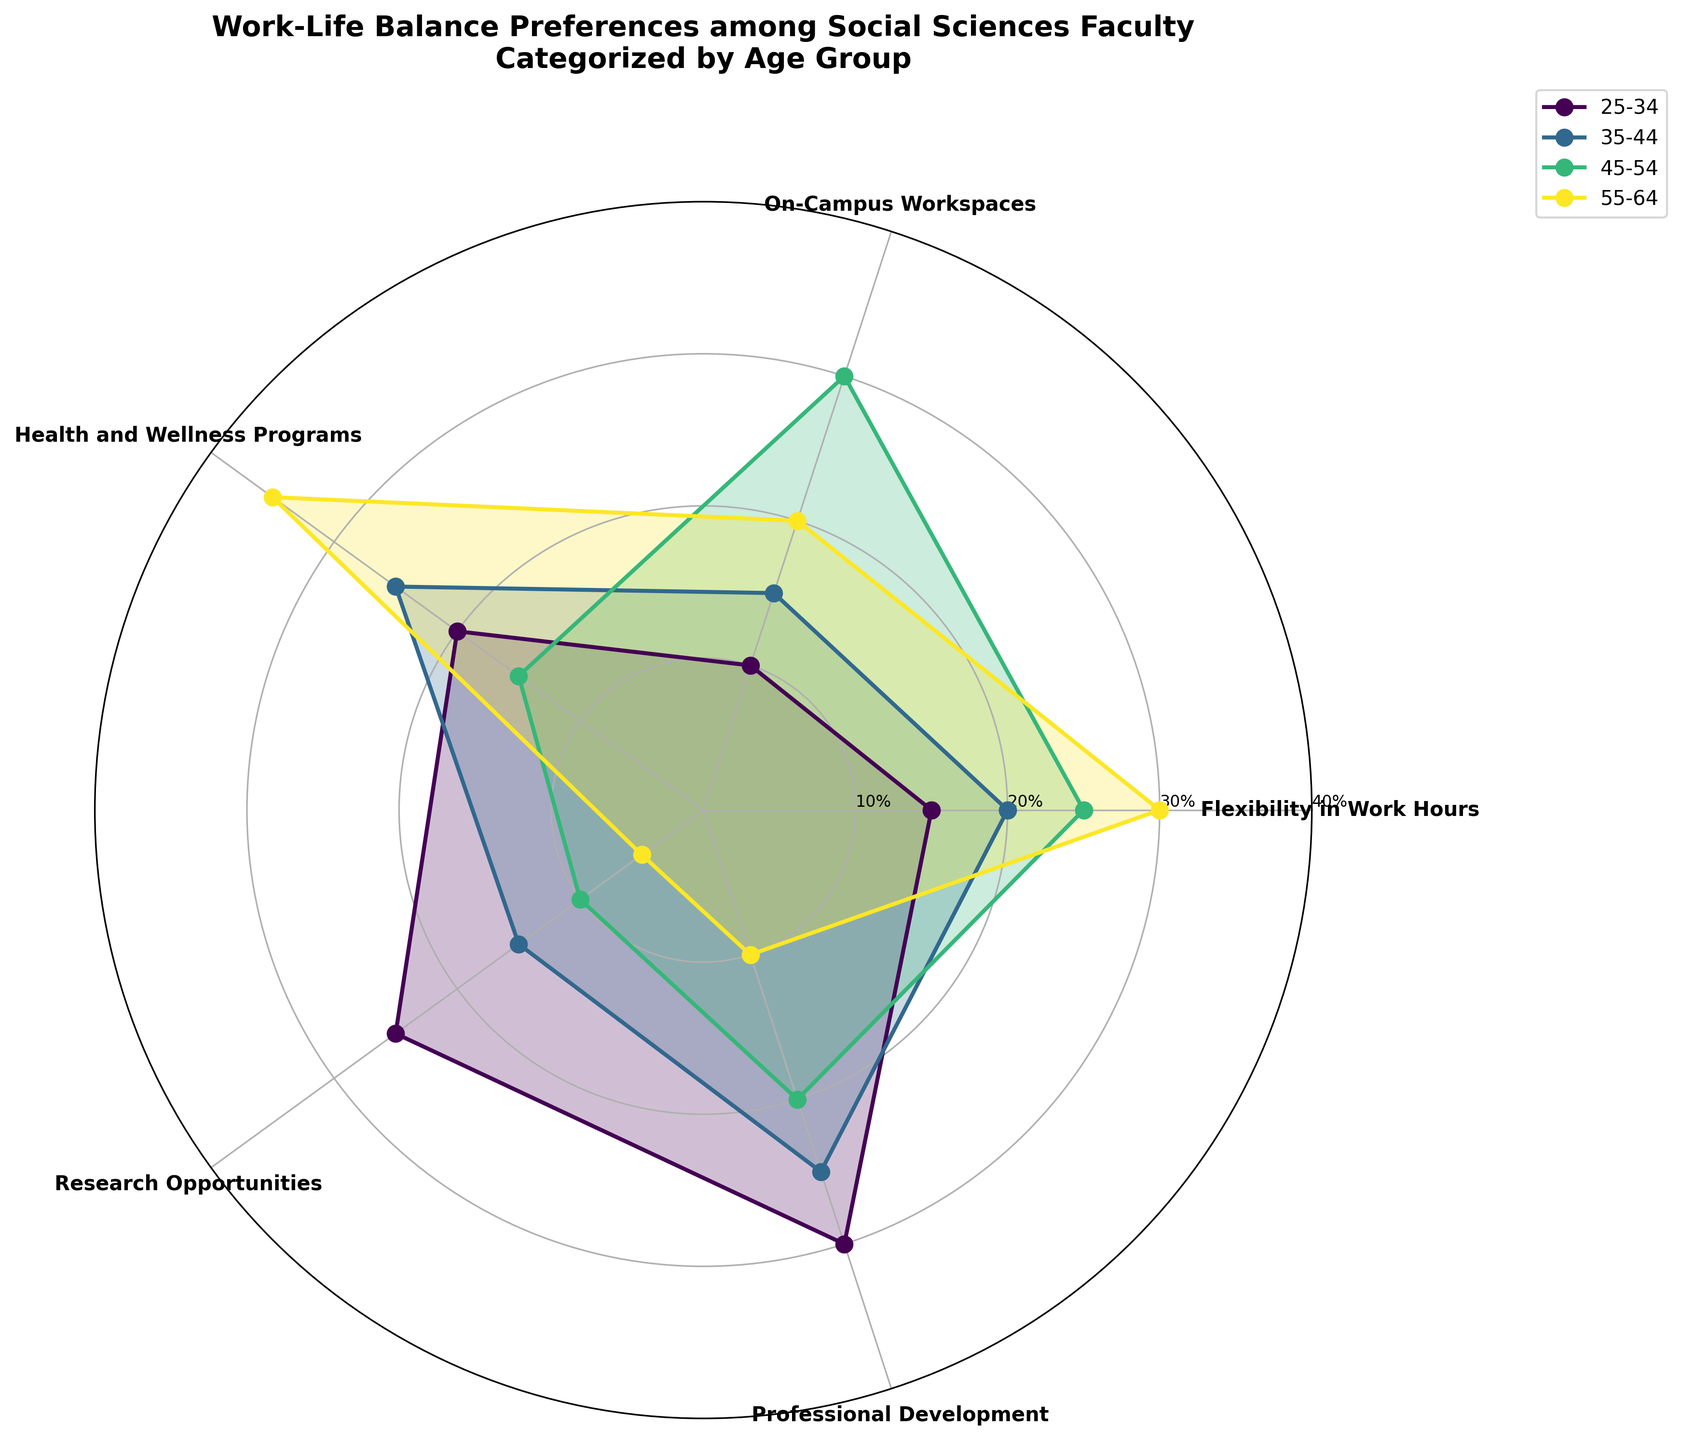What is the title of the polar area chart? The title of the chart is displayed at the top of the figure as text in bold.
Answer: Work-Life Balance Preferences among Social Sciences Faculty Categorized by Age Group What is the age group with the highest preference for "Health and Wellness Programs"? Look at the segment of the polar chart labeled "Health and Wellness Programs" and identify which age group has the largest corresponding value.
Answer: 55-64 Which preference has the lowest value for the 55-64 age group? Find the 55-64 dataset and look at the values, identifying the minimum percentage.
Answer: Research Opportunities How many age groups are compared in the chart? Count all the distinct age groups represented by different lines and colors on the chart.
Answer: Four Comparing "Flexibility in Work Hours" for age groups 25-34 and 55-64, which group reports a higher preference, and by what percentage difference? Identify the values for "Flexibility in Work Hours" in both age groups, and calculate the difference.
Answer: 55-64 reports higher preference by 15% What is the combined percentage preference for "Professional Development" and "Research Opportunities" in the 35-44 age group? Sum the percentages for "Professional Development" and "Research Opportunities" in the 35-44 age group.
Answer: 40% Which age group shows the greatest diversity in preference percentages? Assess which age group has the widest range between its highest and lowest preference percentages.
Answer: 55-64 Which preference category has the smallest range in preference values across all age groups? Compare the ranges of preference values for each preference category by finding the difference between the highest and lowest percentages across all age groups.
Answer: Health and Wellness Programs How do the preferences of "Flexibility in Work Hours" and "On-Campus Workspaces" compare for the age group 45-54? Look at both preference values for "Flexibility in Work Hours" and "On-Campus Workspaces" for the age group 45-54 and directly compare them.
Answer: Flexibility in Work Hours is lower by 5% 